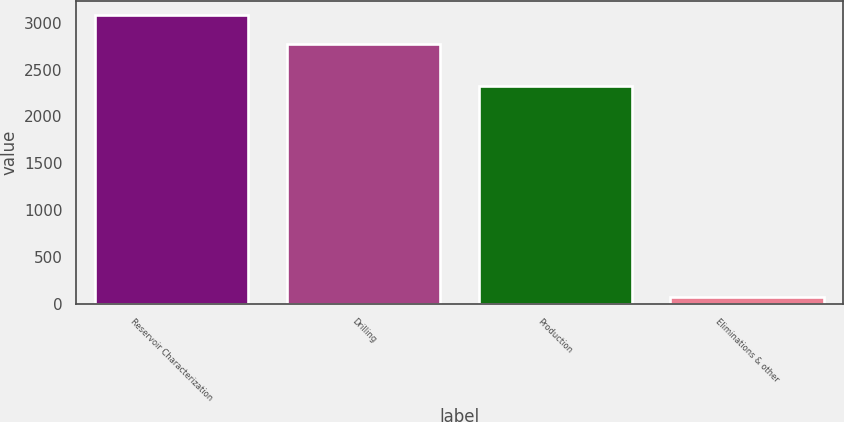Convert chart to OTSL. <chart><loc_0><loc_0><loc_500><loc_500><bar_chart><fcel>Reservoir Characterization<fcel>Drilling<fcel>Production<fcel>Eliminations & other<nl><fcel>3080<fcel>2778<fcel>2327<fcel>68<nl></chart> 